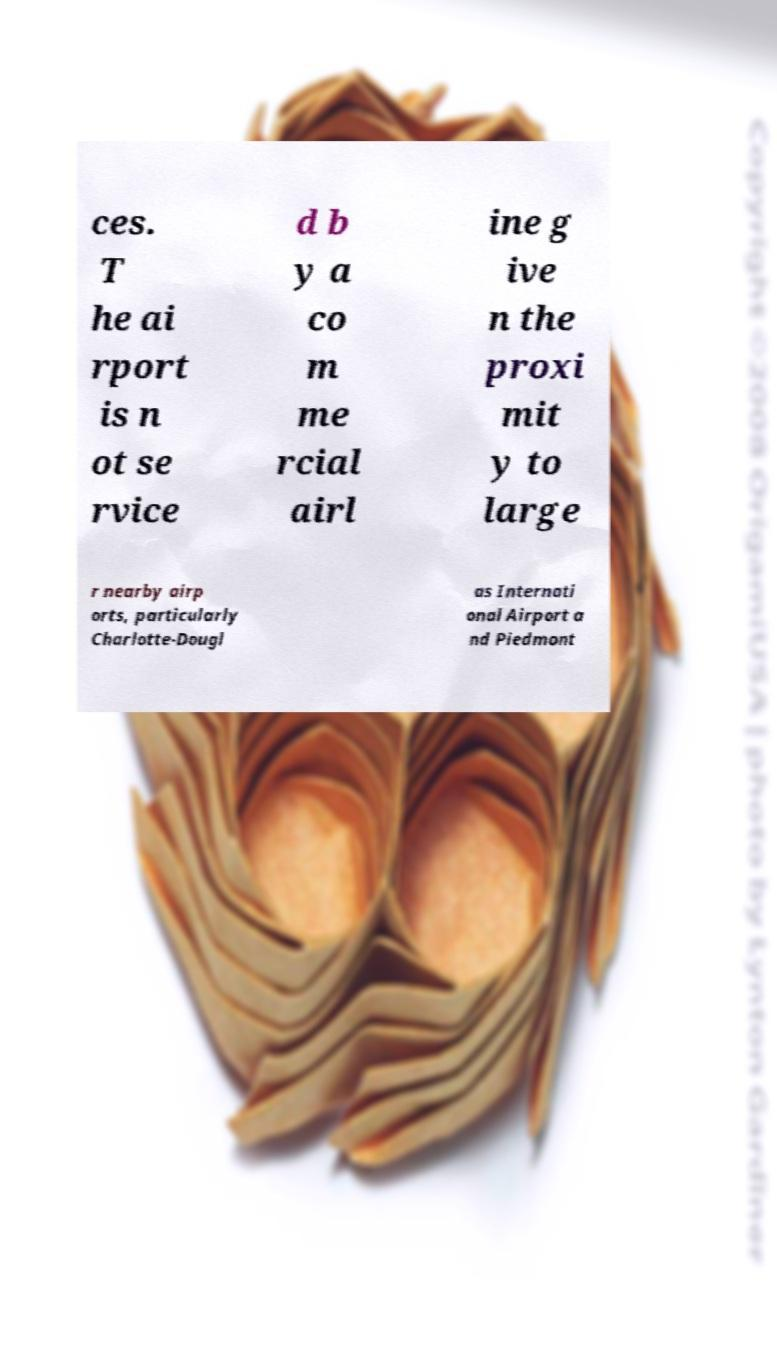Please read and relay the text visible in this image. What does it say? ces. T he ai rport is n ot se rvice d b y a co m me rcial airl ine g ive n the proxi mit y to large r nearby airp orts, particularly Charlotte-Dougl as Internati onal Airport a nd Piedmont 